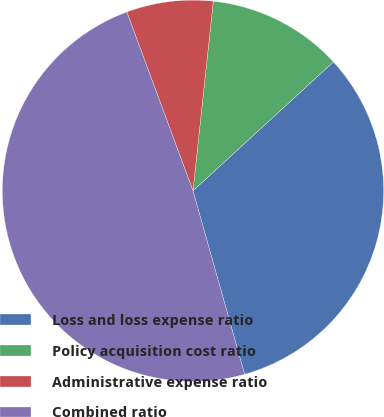Convert chart. <chart><loc_0><loc_0><loc_500><loc_500><pie_chart><fcel>Loss and loss expense ratio<fcel>Policy acquisition cost ratio<fcel>Administrative expense ratio<fcel>Combined ratio<nl><fcel>32.45%<fcel>11.48%<fcel>7.34%<fcel>48.73%<nl></chart> 